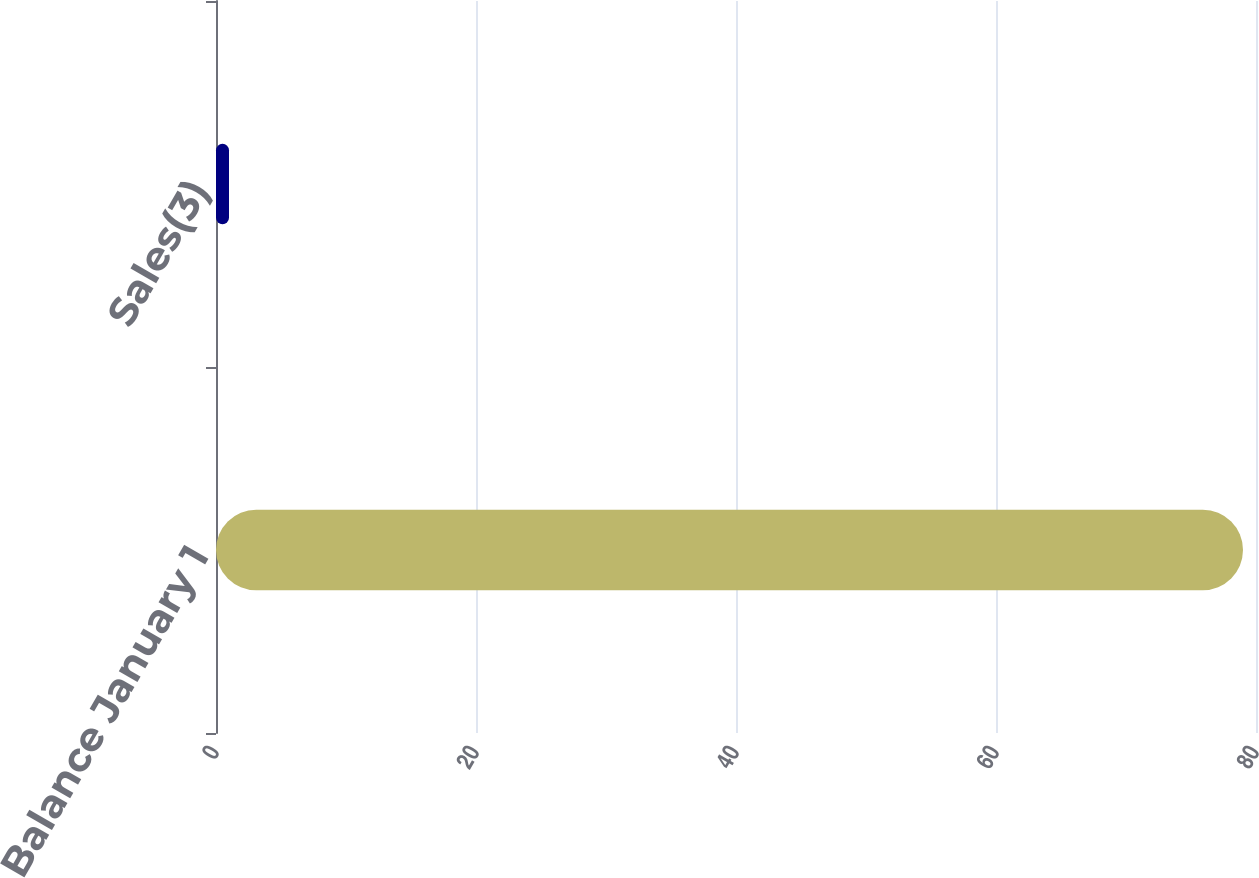Convert chart to OTSL. <chart><loc_0><loc_0><loc_500><loc_500><bar_chart><fcel>Balance January 1<fcel>Sales(3)<nl><fcel>79<fcel>1<nl></chart> 